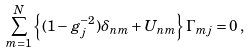<formula> <loc_0><loc_0><loc_500><loc_500>\sum _ { m = 1 } ^ { N } \left \{ ( 1 - g _ { j } ^ { - 2 } ) \delta _ { n m } + U _ { n m } \right \} \Gamma _ { m j } = 0 \, ,</formula> 